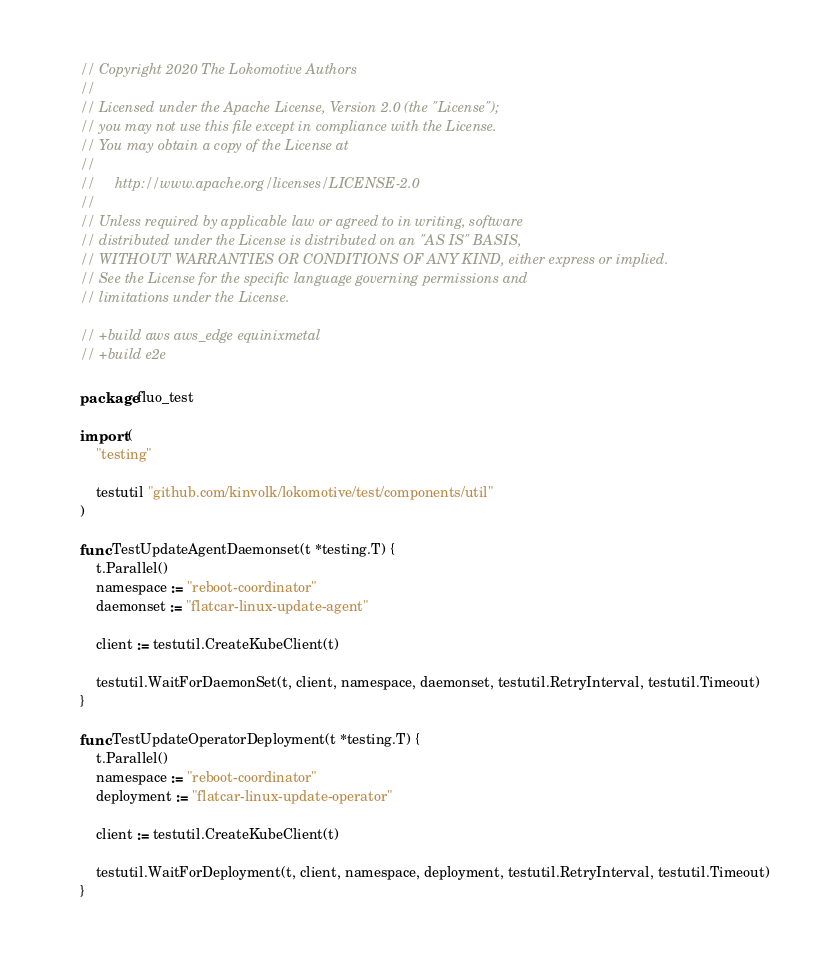<code> <loc_0><loc_0><loc_500><loc_500><_Go_>// Copyright 2020 The Lokomotive Authors
//
// Licensed under the Apache License, Version 2.0 (the "License");
// you may not use this file except in compliance with the License.
// You may obtain a copy of the License at
//
//     http://www.apache.org/licenses/LICENSE-2.0
//
// Unless required by applicable law or agreed to in writing, software
// distributed under the License is distributed on an "AS IS" BASIS,
// WITHOUT WARRANTIES OR CONDITIONS OF ANY KIND, either express or implied.
// See the License for the specific language governing permissions and
// limitations under the License.

// +build aws aws_edge equinixmetal
// +build e2e

package fluo_test

import (
	"testing"

	testutil "github.com/kinvolk/lokomotive/test/components/util"
)

func TestUpdateAgentDaemonset(t *testing.T) {
	t.Parallel()
	namespace := "reboot-coordinator"
	daemonset := "flatcar-linux-update-agent"

	client := testutil.CreateKubeClient(t)

	testutil.WaitForDaemonSet(t, client, namespace, daemonset, testutil.RetryInterval, testutil.Timeout)
}

func TestUpdateOperatorDeployment(t *testing.T) {
	t.Parallel()
	namespace := "reboot-coordinator"
	deployment := "flatcar-linux-update-operator"

	client := testutil.CreateKubeClient(t)

	testutil.WaitForDeployment(t, client, namespace, deployment, testutil.RetryInterval, testutil.Timeout)
}
</code> 